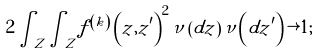<formula> <loc_0><loc_0><loc_500><loc_500>2 \int _ { Z } \int _ { Z } f ^ { \left ( k \right ) } \left ( z , z ^ { \prime } \right ) ^ { 2 } \nu \left ( d z \right ) \nu \left ( d z ^ { \prime } \right ) \rightarrow 1 ;</formula> 